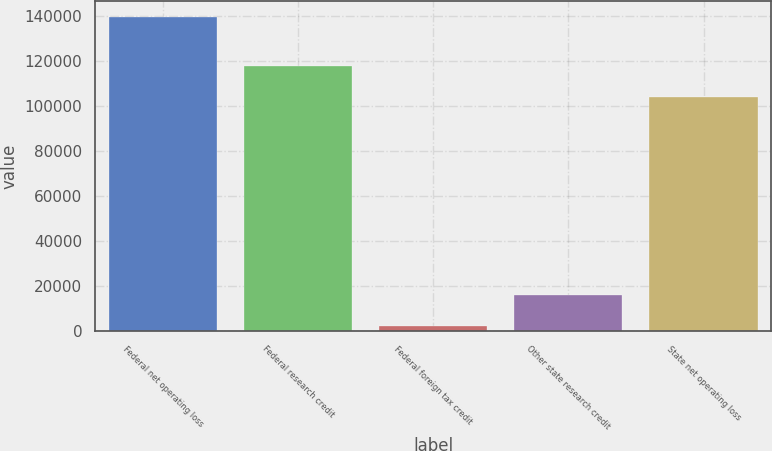<chart> <loc_0><loc_0><loc_500><loc_500><bar_chart><fcel>Federal net operating loss<fcel>Federal research credit<fcel>Federal foreign tax credit<fcel>Other state research credit<fcel>State net operating loss<nl><fcel>139526<fcel>117884<fcel>2427<fcel>16136.9<fcel>104174<nl></chart> 